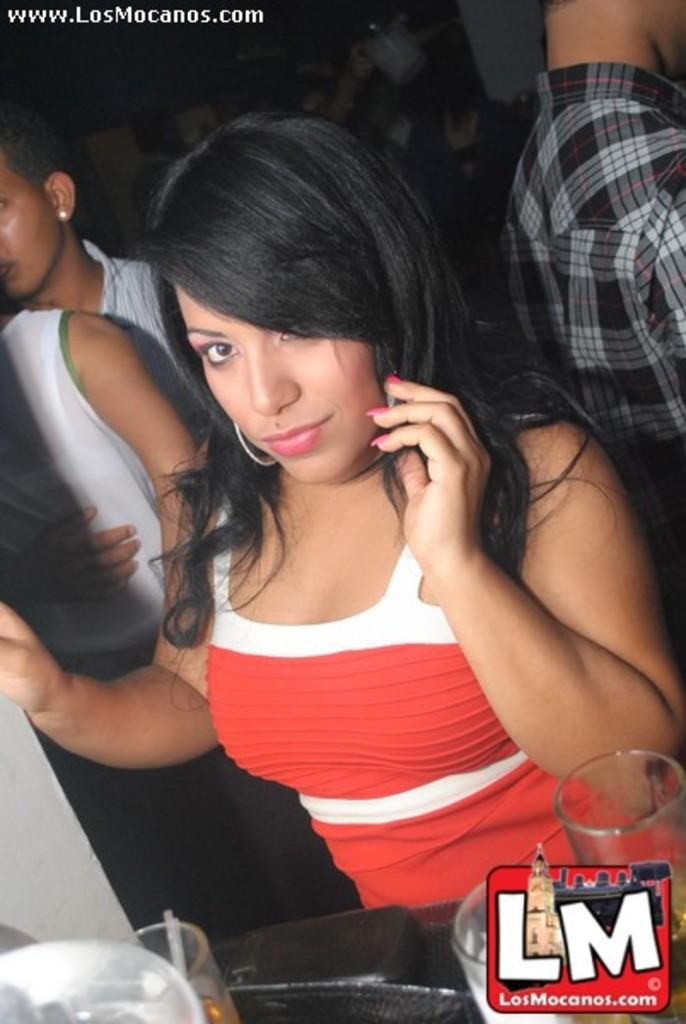Who is the main subject in the image? There is a woman in the center of the image. What objects are at the bottom of the image? There are glasses, a mobile phone, and a table at the bottom of the image. Can you describe the background of the image? There is a group of people in the background of the image. What type of linen is draped over the woman's shoulders in the image? There is no linen draped over the woman's shoulders in the image. What bit of information can you provide about the woman's clothing? The provided facts do not mention any specific details about the woman's clothing. 